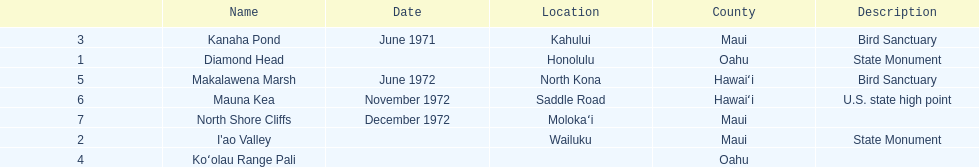What is the number of bird sanctuary landmarks? 2. 